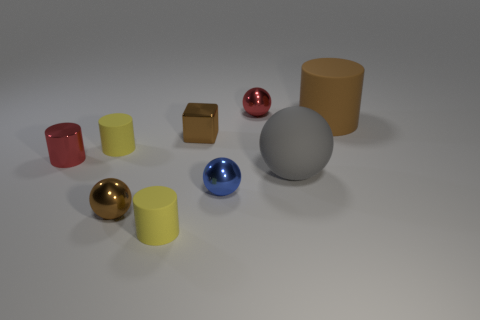How many yellow cylinders must be subtracted to get 1 yellow cylinders? 1 Subtract all cubes. How many objects are left? 8 Subtract 3 balls. How many balls are left? 1 Subtract all cyan cubes. Subtract all green spheres. How many cubes are left? 1 Subtract all red cylinders. How many gray balls are left? 1 Subtract all yellow metallic cylinders. Subtract all red balls. How many objects are left? 8 Add 2 yellow rubber objects. How many yellow rubber objects are left? 4 Add 6 big green shiny spheres. How many big green shiny spheres exist? 6 Subtract all yellow cylinders. How many cylinders are left? 2 Subtract all small cylinders. How many cylinders are left? 1 